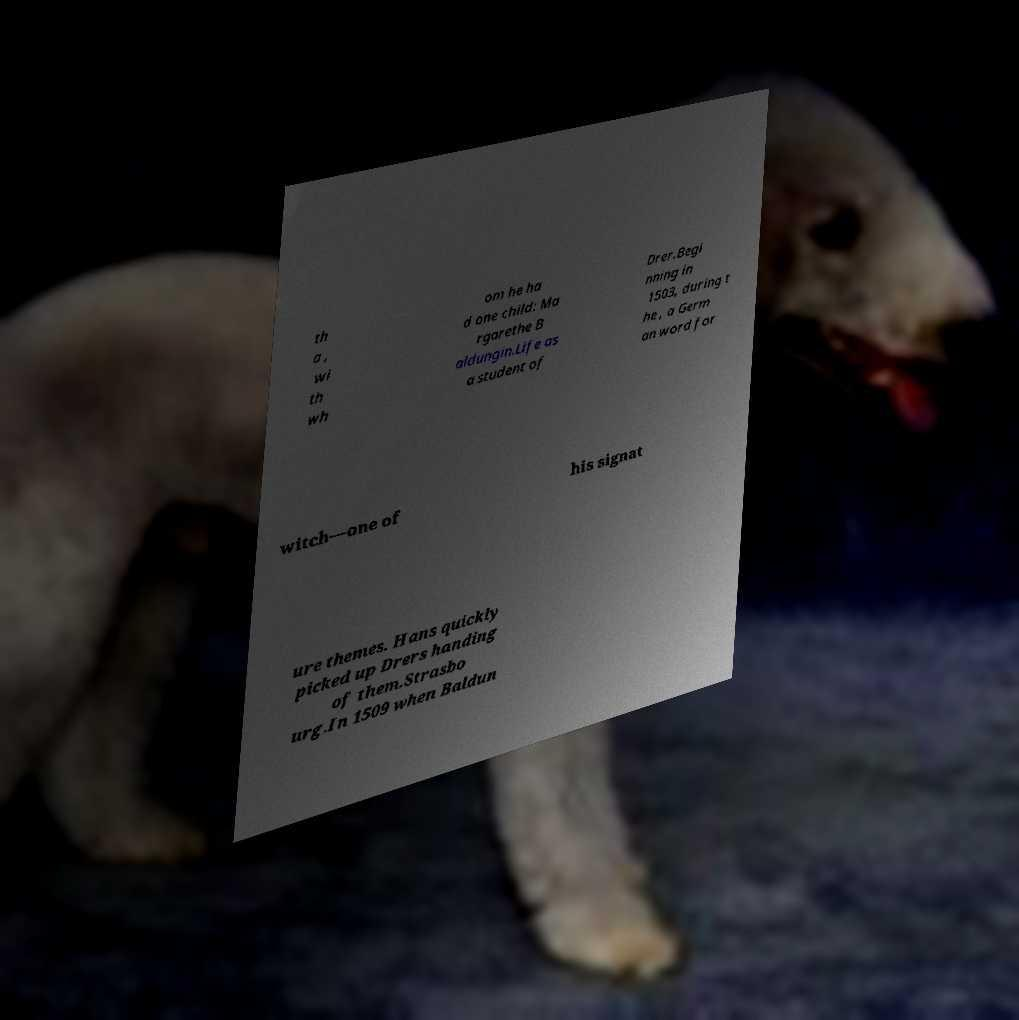Can you accurately transcribe the text from the provided image for me? th a , wi th wh om he ha d one child: Ma rgarethe B aldungin.Life as a student of Drer.Begi nning in 1503, during t he , a Germ an word for witch—one of his signat ure themes. Hans quickly picked up Drers handing of them.Strasbo urg.In 1509 when Baldun 